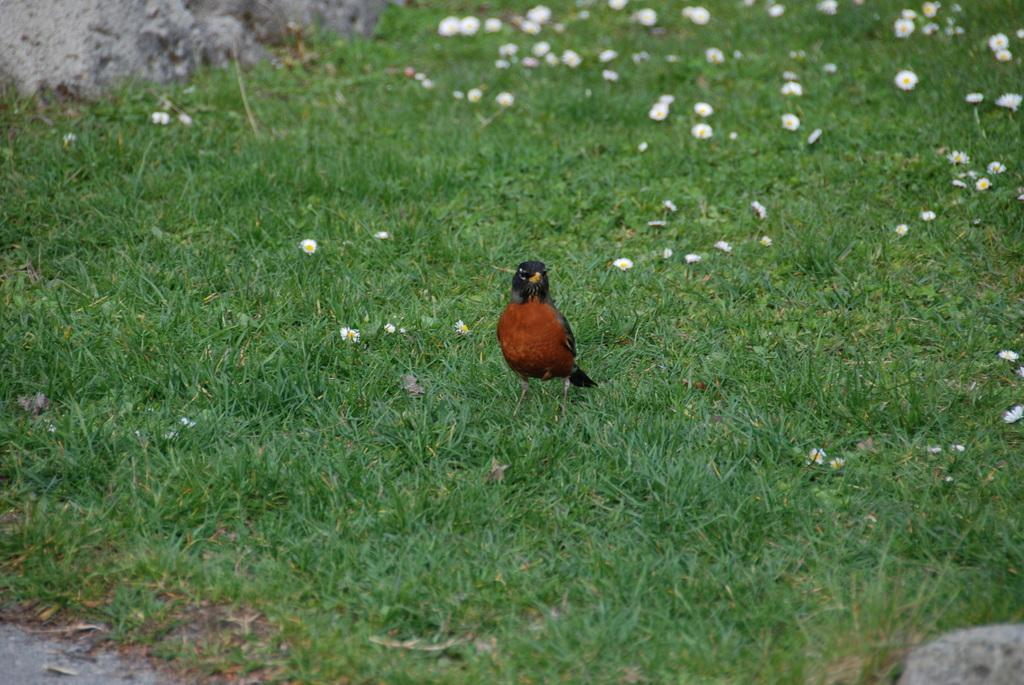What type of animal is in the image? There is a bird in the image. Where is the bird located in the image? The bird is in the center of the image. What is the bird standing on? The bird is on the grass. What type of temper does the bird have in the image? There is no indication of the bird's temper in the image, as it is a still image and does not show any emotions or behaviors. 